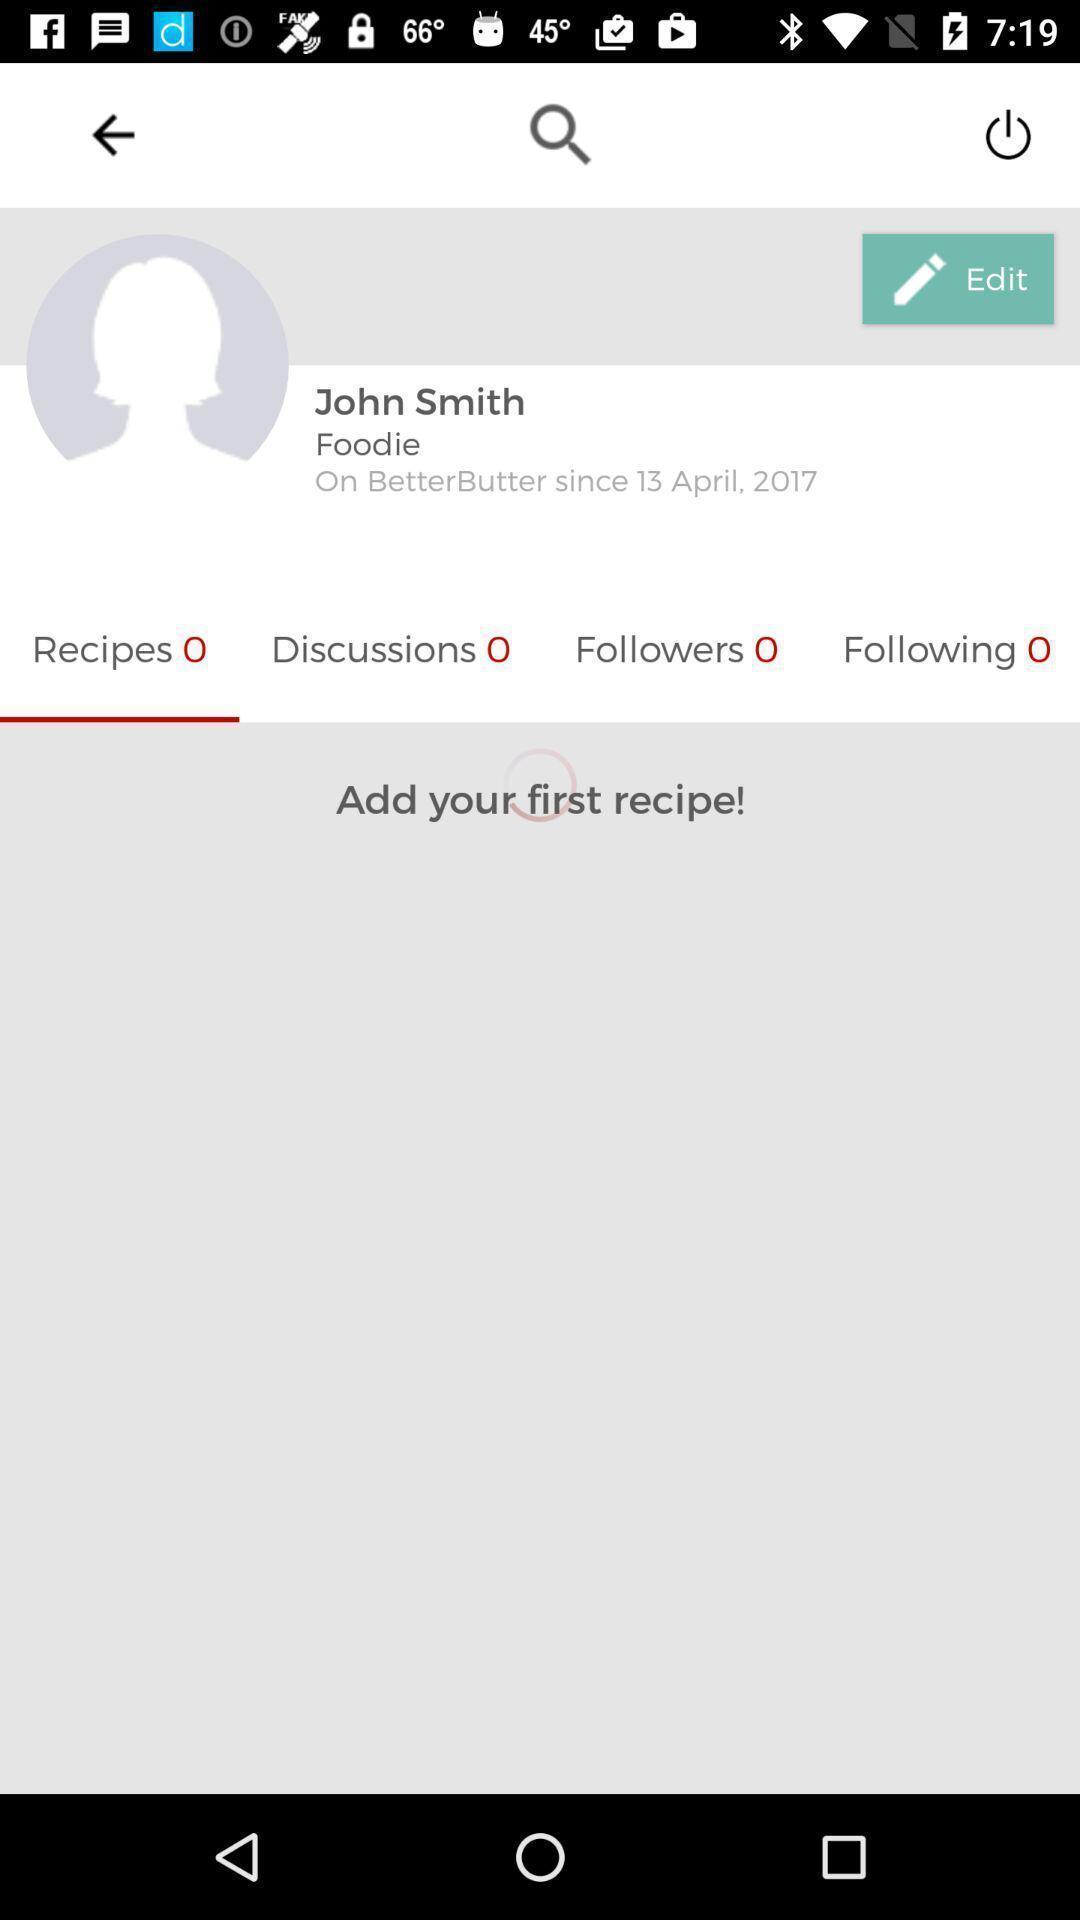Give me a summary of this screen capture. Profile page. 